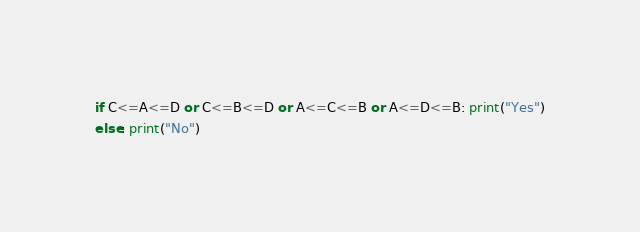<code> <loc_0><loc_0><loc_500><loc_500><_Python_>if C<=A<=D or C<=B<=D or A<=C<=B or A<=D<=B: print("Yes")
else: print("No")</code> 